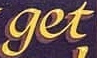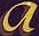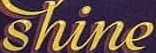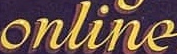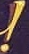What text appears in these images from left to right, separated by a semicolon? get; a; shine; online; ! 